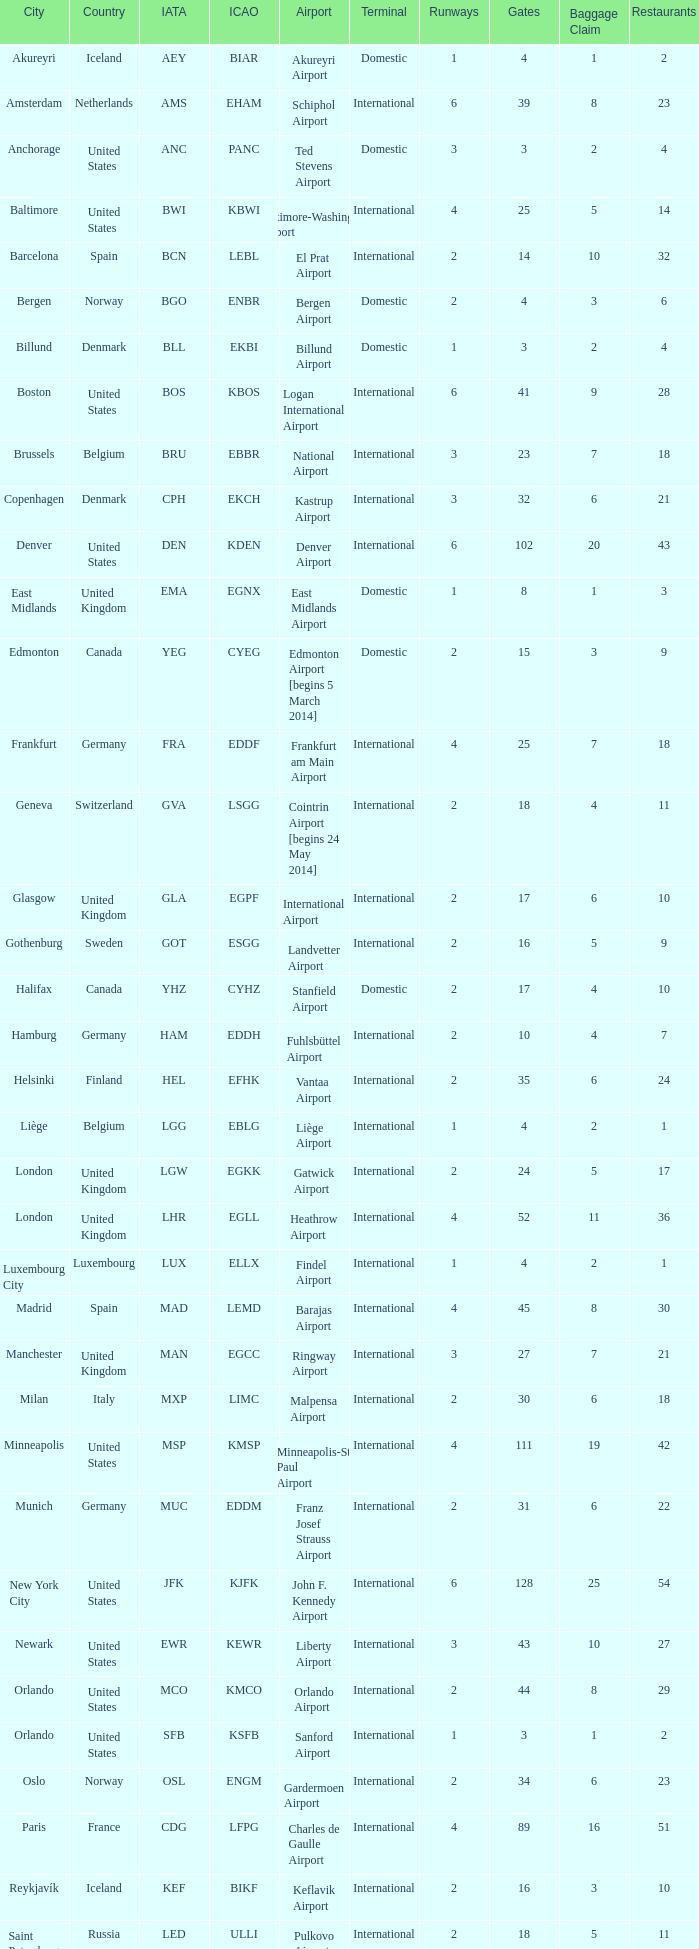What is the Airport with the ICAO fo KSEA? Seattle–Tacoma Airport. 